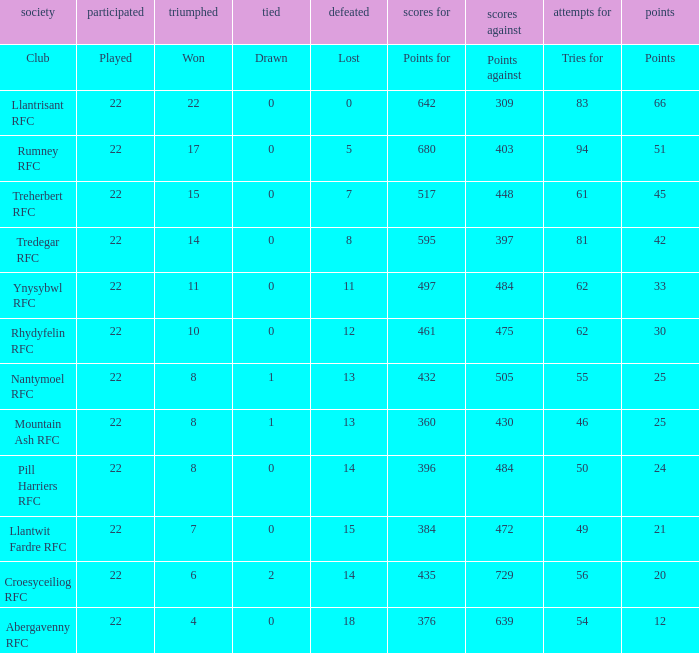How many matches were drawn by the teams that won exactly 10? 1.0. 